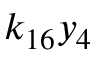<formula> <loc_0><loc_0><loc_500><loc_500>k _ { 1 6 } y _ { 4 }</formula> 